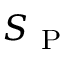<formula> <loc_0><loc_0><loc_500><loc_500>S _ { P }</formula> 